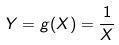<formula> <loc_0><loc_0><loc_500><loc_500>Y = g ( X ) = \frac { 1 } { X }</formula> 